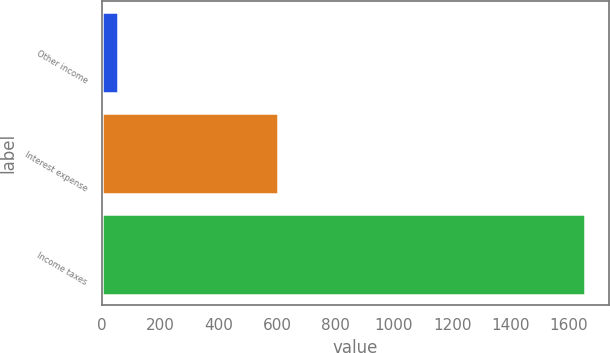<chart> <loc_0><loc_0><loc_500><loc_500><bar_chart><fcel>Other income<fcel>Interest expense<fcel>Income taxes<nl><fcel>54<fcel>602<fcel>1653<nl></chart> 